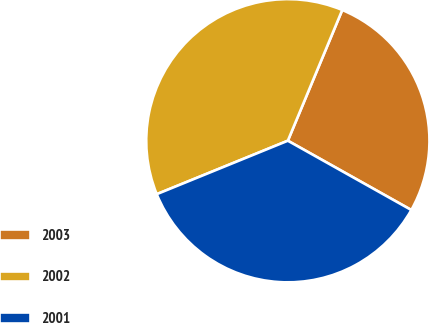Convert chart to OTSL. <chart><loc_0><loc_0><loc_500><loc_500><pie_chart><fcel>2003<fcel>2002<fcel>2001<nl><fcel>26.86%<fcel>37.44%<fcel>35.7%<nl></chart> 